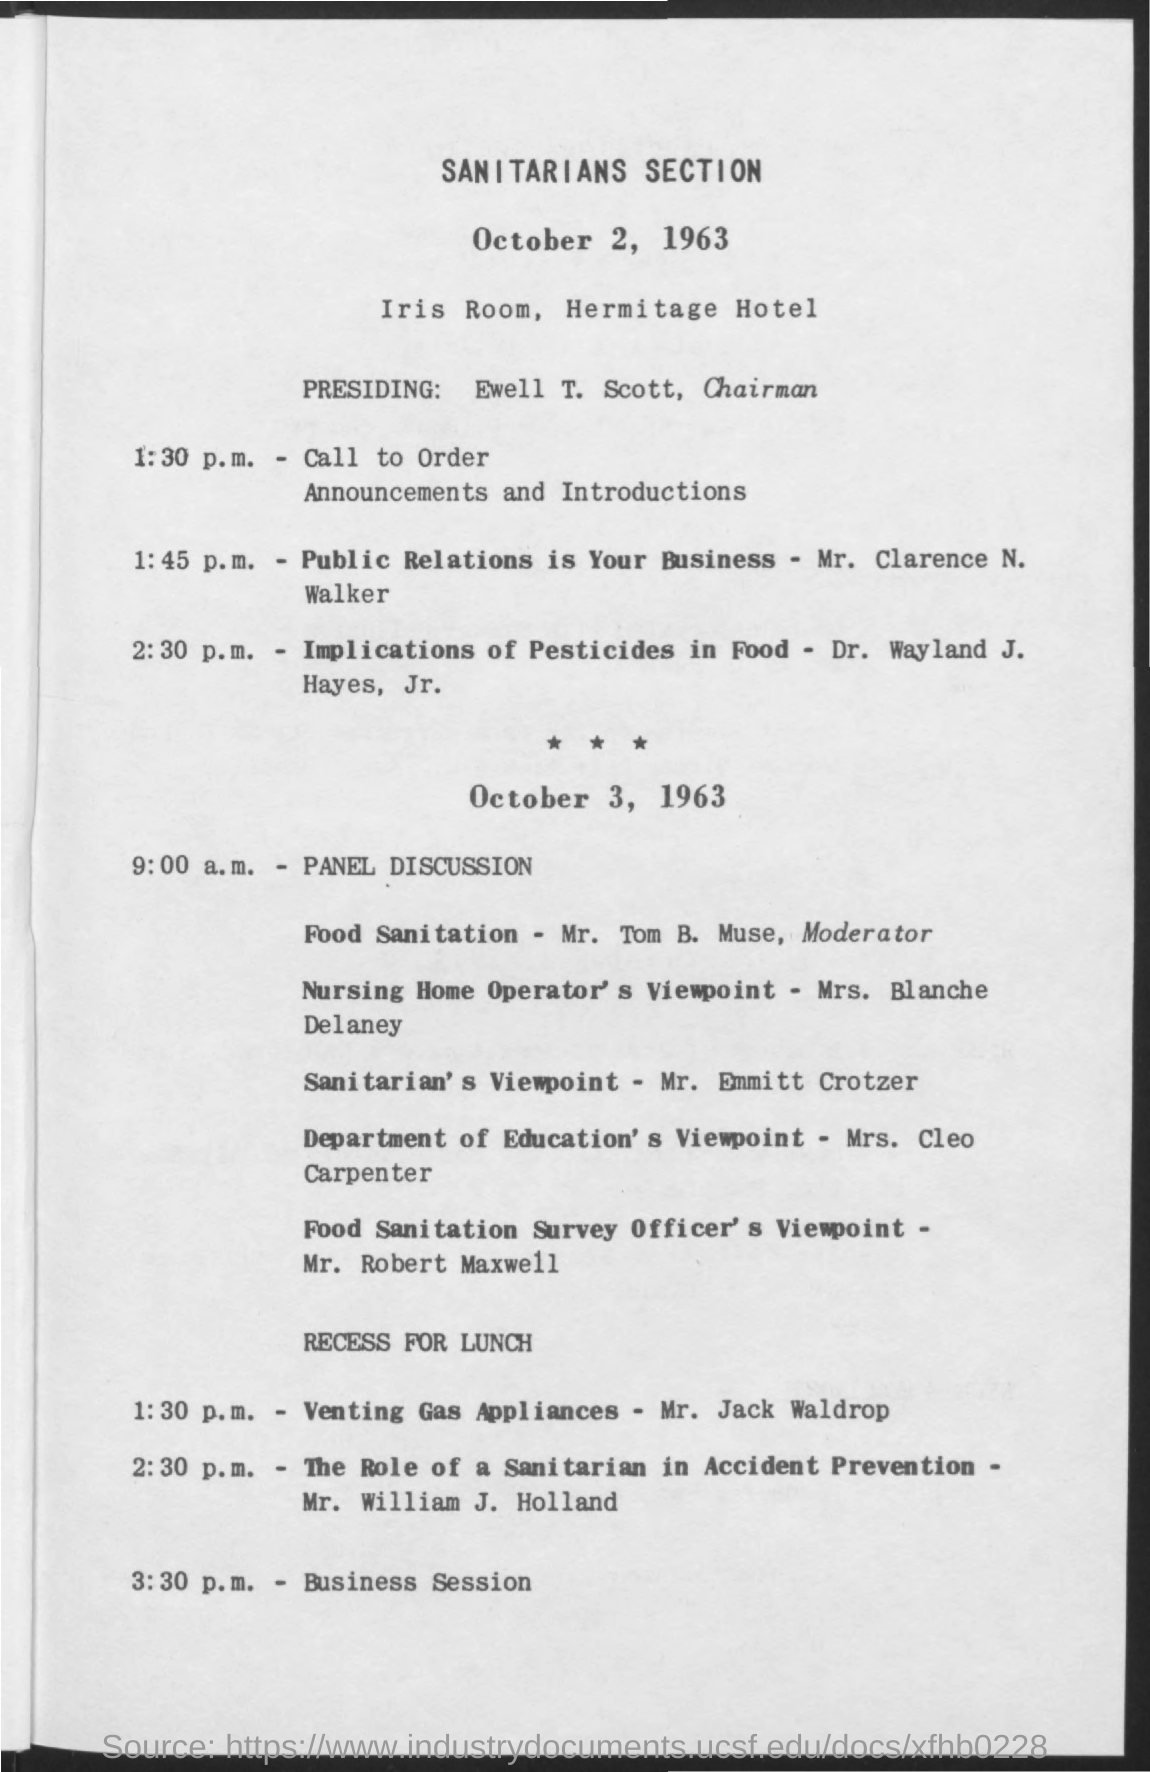Who was the chairman presiding over the meeting, and what might that role entail? The chairman presiding over the meeting was Ewell T. Scott. As the chairman, Ewell would have been responsible for overseeing the meeting, ensuring that the agenda was followed, managing discussions, and facilitating a smooth conduct of the event. 